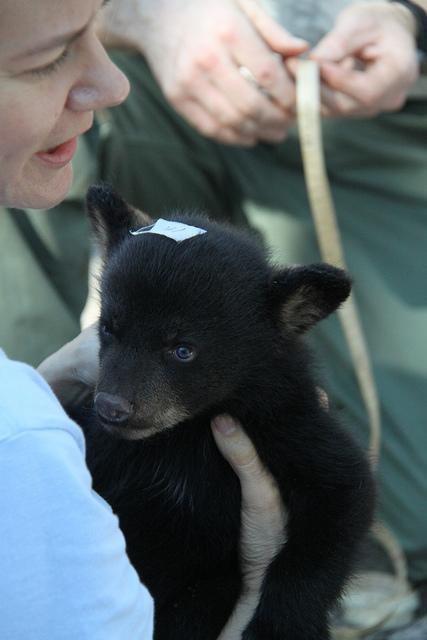Is this bear hurt?
Short answer required. Yes. Are the people most likely veterinarians?
Write a very short answer. Yes. Why is the animal tied?
Quick response, please. Wild. Is this a normal house pet?
Short answer required. No. 